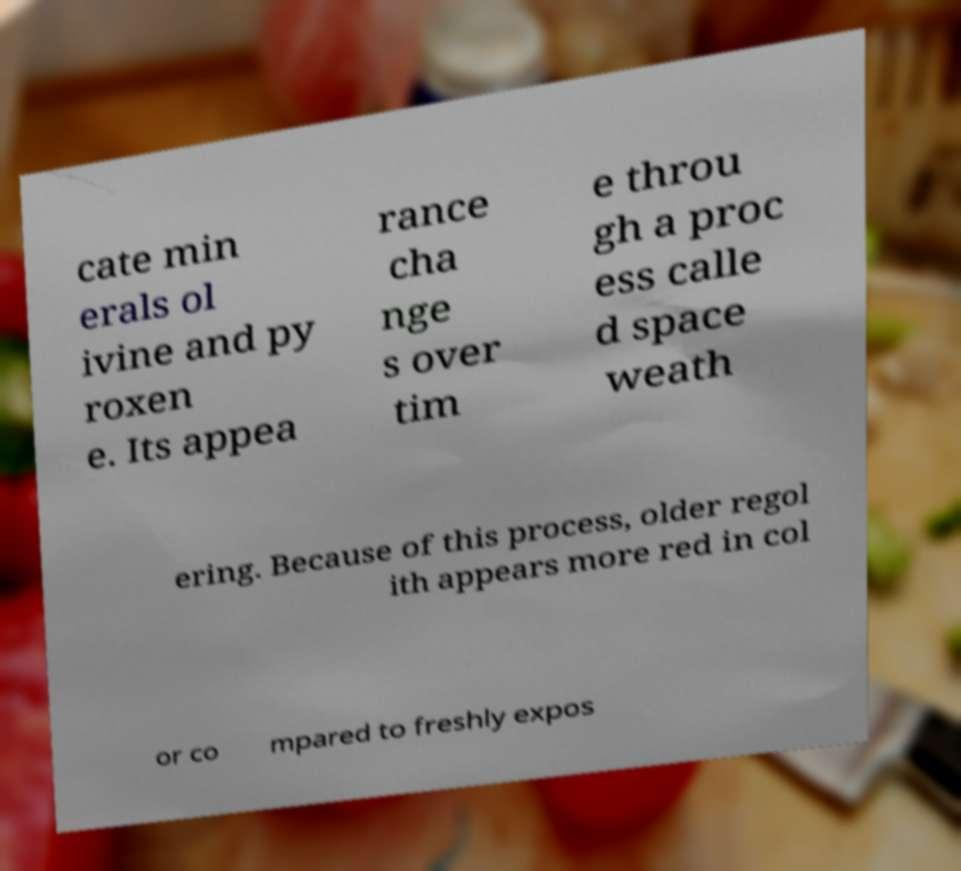Please identify and transcribe the text found in this image. cate min erals ol ivine and py roxen e. Its appea rance cha nge s over tim e throu gh a proc ess calle d space weath ering. Because of this process, older regol ith appears more red in col or co mpared to freshly expos 